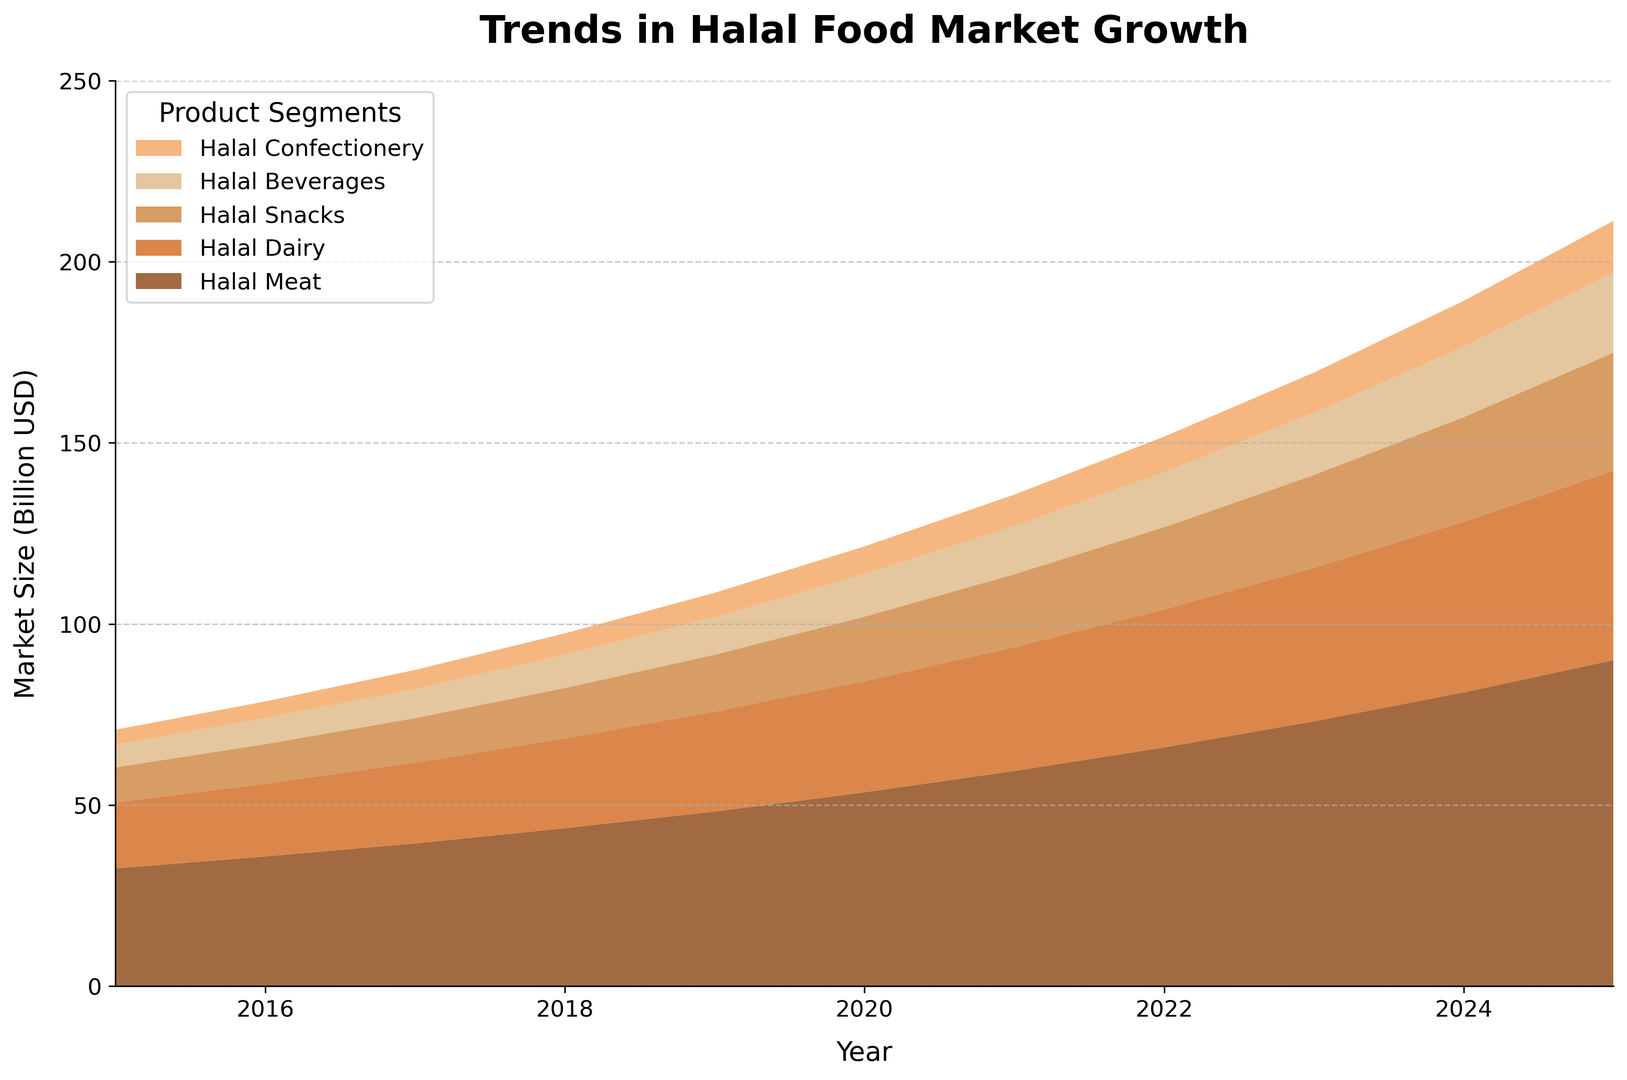What is the total projected market size of Halal Meat and Halal Dairy in 2025? First, locate the market size of Halal Meat in 2025, which is 90.0 billion USD. Then, locate the market size of Halal Dairy in 2025, which is 52.3 billion USD. Add these values together, 90.0 + 52.3 = 142.3 billion USD.
Answer: 142.3 billion USD Which product segment had the highest market size in 2018, and what is the value? Observe the height of each segment in 2018. Halal Meat stands out as the tallest segment. Its market size is 43.6 billion USD.
Answer: Halal Meat, 43.6 billion USD How much did the Halal Beverages market grow between 2016 and 2019? Find the market size of Halal Beverages in 2016, which is 7.2 billion USD, and in 2019, which is 10.4 billion USD. Subtract the 2016 value from the 2019 value: 10.4 - 7.2 = 3.2 billion USD.
Answer: 3.2 billion USD Among the product segments, which had the largest relative increase in market size from 2015 to 2025? Calculate relative increases for each segment. For Halal Meat: (90.0 - 32.5) / 32.5 ≈ 1.77 (or 177%). For Halal Dairy: (52.3 - 18.2) / 18.2 ≈ 1.87 (or 187%). For Halal Snacks: (32.6 - 9.7) / 9.7 ≈ 2.36 (or 236%). For Halal Beverages: (22.1 - 6.3) / 6.3 ≈ 2.51 (or 251%). For Halal Confectionery: (14.3 - 4.1) / 4.1 ≈ 2.49 (or 249%). Halal Beverages has the largest relative increase at 251%.
Answer: Halal Beverages What was the average market size of Halal Snacks from 2015 to 2020? Sum up the market sizes from 2015 to 2020: 9.7 + 10.9 + 12.3 + 13.9 + 15.7 + 17.8 = 70.3. Divide by the number of years (6): 70.3 / 6 ≈ 11.72 billion USD.
Answer: 11.72 billion USD What is the difference in market size between Halal Dairy and Halal Confectionery in 2023? Find the market size of Halal Dairy in 2023, which is 42.4 billion USD, and Halal Confectionery in 2023, which is 11.1 billion USD. Subtract the value of Halal Confectionery from Halal Dairy: 42.4 - 11.1 = 31.3 billion USD.
Answer: 31.3 billion USD Which product segment showed the smallest increase in market size between 2019 and 2024? Calculate the increases for each segment: Halal Meat: 81.1 - 48.2 = 32.9, Halal Dairy: 47.1 - 27.6 = 19.5, Halal Snacks: 28.9 - 15.7 = 13.2, Halal Beverages: 19.5 - 10.4 = 9.1, Halal Confectionery: 12.6 - 6.7 = 5.9. The smallest increase is for Halal Confectionery.
Answer: Halal Confectionery 